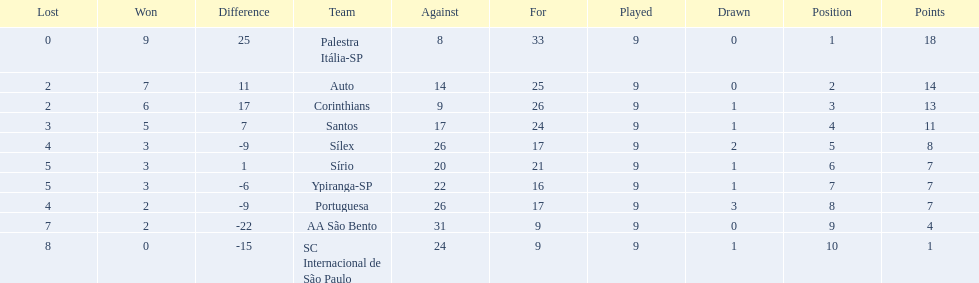Brazilian football in 1926 what teams had no draws? Palestra Itália-SP, Auto, AA São Bento. Of the teams with no draws name the 2 who lost the lease. Palestra Itália-SP, Auto. What team of the 2 who lost the least and had no draws had the highest difference? Palestra Itália-SP. 